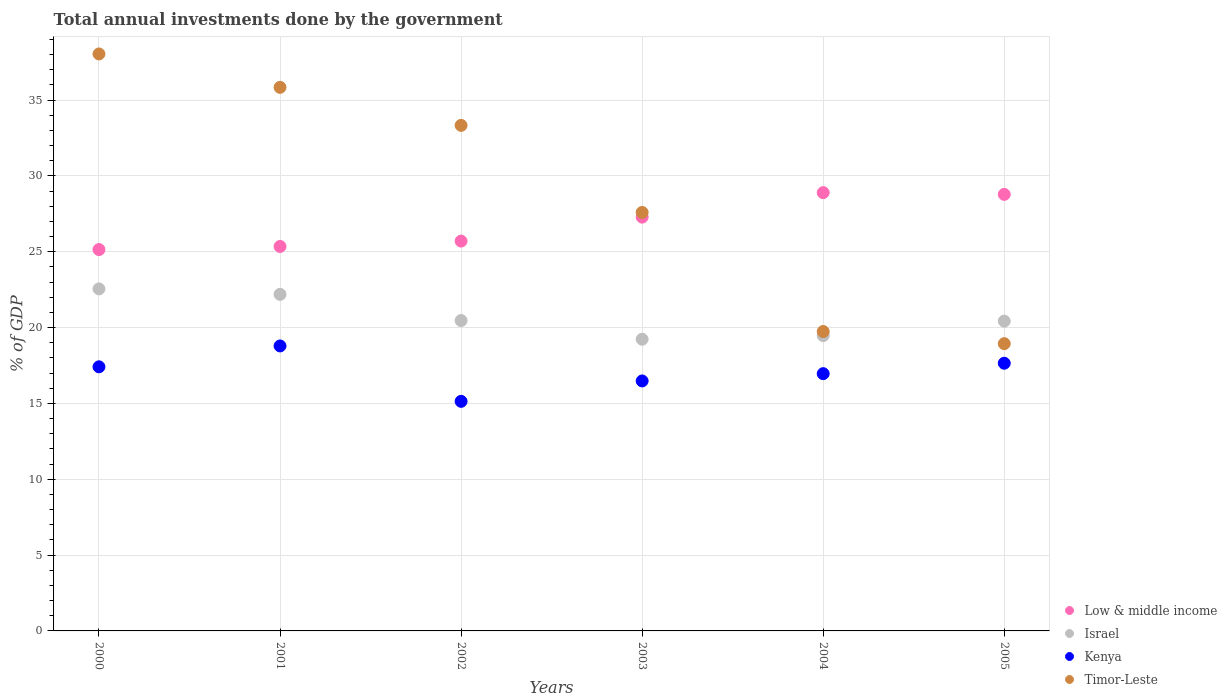How many different coloured dotlines are there?
Your answer should be compact. 4. What is the total annual investments done by the government in Kenya in 2002?
Your answer should be very brief. 15.14. Across all years, what is the maximum total annual investments done by the government in Timor-Leste?
Keep it short and to the point. 38.04. Across all years, what is the minimum total annual investments done by the government in Timor-Leste?
Offer a terse response. 18.94. What is the total total annual investments done by the government in Timor-Leste in the graph?
Offer a very short reply. 173.49. What is the difference between the total annual investments done by the government in Israel in 2001 and that in 2003?
Keep it short and to the point. 2.96. What is the difference between the total annual investments done by the government in Israel in 2004 and the total annual investments done by the government in Low & middle income in 2001?
Give a very brief answer. -5.88. What is the average total annual investments done by the government in Israel per year?
Give a very brief answer. 20.72. In the year 2005, what is the difference between the total annual investments done by the government in Timor-Leste and total annual investments done by the government in Israel?
Provide a short and direct response. -1.49. What is the ratio of the total annual investments done by the government in Kenya in 2004 to that in 2005?
Offer a very short reply. 0.96. What is the difference between the highest and the second highest total annual investments done by the government in Israel?
Offer a very short reply. 0.36. What is the difference between the highest and the lowest total annual investments done by the government in Low & middle income?
Give a very brief answer. 3.75. Is the sum of the total annual investments done by the government in Low & middle income in 2000 and 2003 greater than the maximum total annual investments done by the government in Kenya across all years?
Keep it short and to the point. Yes. Is it the case that in every year, the sum of the total annual investments done by the government in Israel and total annual investments done by the government in Timor-Leste  is greater than the sum of total annual investments done by the government in Low & middle income and total annual investments done by the government in Kenya?
Give a very brief answer. No. Is it the case that in every year, the sum of the total annual investments done by the government in Timor-Leste and total annual investments done by the government in Low & middle income  is greater than the total annual investments done by the government in Israel?
Ensure brevity in your answer.  Yes. How many dotlines are there?
Give a very brief answer. 4. What is the difference between two consecutive major ticks on the Y-axis?
Provide a succinct answer. 5. Are the values on the major ticks of Y-axis written in scientific E-notation?
Your answer should be very brief. No. Does the graph contain any zero values?
Your response must be concise. No. Does the graph contain grids?
Keep it short and to the point. Yes. How are the legend labels stacked?
Your response must be concise. Vertical. What is the title of the graph?
Your answer should be compact. Total annual investments done by the government. Does "Bahrain" appear as one of the legend labels in the graph?
Offer a terse response. No. What is the label or title of the Y-axis?
Make the answer very short. % of GDP. What is the % of GDP of Low & middle income in 2000?
Ensure brevity in your answer.  25.15. What is the % of GDP of Israel in 2000?
Your answer should be very brief. 22.55. What is the % of GDP of Kenya in 2000?
Make the answer very short. 17.41. What is the % of GDP in Timor-Leste in 2000?
Offer a very short reply. 38.04. What is the % of GDP in Low & middle income in 2001?
Your response must be concise. 25.35. What is the % of GDP in Israel in 2001?
Keep it short and to the point. 22.19. What is the % of GDP in Kenya in 2001?
Keep it short and to the point. 18.79. What is the % of GDP in Timor-Leste in 2001?
Keep it short and to the point. 35.84. What is the % of GDP in Low & middle income in 2002?
Offer a terse response. 25.7. What is the % of GDP of Israel in 2002?
Your answer should be compact. 20.47. What is the % of GDP in Kenya in 2002?
Offer a terse response. 15.14. What is the % of GDP of Timor-Leste in 2002?
Your answer should be very brief. 33.33. What is the % of GDP of Low & middle income in 2003?
Provide a succinct answer. 27.28. What is the % of GDP in Israel in 2003?
Offer a very short reply. 19.23. What is the % of GDP in Kenya in 2003?
Keep it short and to the point. 16.48. What is the % of GDP in Timor-Leste in 2003?
Your answer should be compact. 27.59. What is the % of GDP in Low & middle income in 2004?
Your answer should be very brief. 28.9. What is the % of GDP in Israel in 2004?
Your response must be concise. 19.47. What is the % of GDP in Kenya in 2004?
Offer a terse response. 16.96. What is the % of GDP of Timor-Leste in 2004?
Ensure brevity in your answer.  19.74. What is the % of GDP of Low & middle income in 2005?
Provide a short and direct response. 28.78. What is the % of GDP of Israel in 2005?
Give a very brief answer. 20.43. What is the % of GDP of Kenya in 2005?
Your answer should be compact. 17.65. What is the % of GDP of Timor-Leste in 2005?
Give a very brief answer. 18.94. Across all years, what is the maximum % of GDP of Low & middle income?
Offer a terse response. 28.9. Across all years, what is the maximum % of GDP of Israel?
Provide a succinct answer. 22.55. Across all years, what is the maximum % of GDP of Kenya?
Provide a short and direct response. 18.79. Across all years, what is the maximum % of GDP of Timor-Leste?
Offer a very short reply. 38.04. Across all years, what is the minimum % of GDP of Low & middle income?
Ensure brevity in your answer.  25.15. Across all years, what is the minimum % of GDP in Israel?
Give a very brief answer. 19.23. Across all years, what is the minimum % of GDP of Kenya?
Your answer should be compact. 15.14. Across all years, what is the minimum % of GDP in Timor-Leste?
Your answer should be compact. 18.94. What is the total % of GDP in Low & middle income in the graph?
Your answer should be very brief. 161.16. What is the total % of GDP in Israel in the graph?
Your response must be concise. 124.34. What is the total % of GDP of Kenya in the graph?
Provide a succinct answer. 102.44. What is the total % of GDP of Timor-Leste in the graph?
Provide a succinct answer. 173.49. What is the difference between the % of GDP in Low & middle income in 2000 and that in 2001?
Offer a terse response. -0.2. What is the difference between the % of GDP in Israel in 2000 and that in 2001?
Offer a very short reply. 0.36. What is the difference between the % of GDP of Kenya in 2000 and that in 2001?
Give a very brief answer. -1.38. What is the difference between the % of GDP in Timor-Leste in 2000 and that in 2001?
Provide a succinct answer. 2.2. What is the difference between the % of GDP of Low & middle income in 2000 and that in 2002?
Provide a short and direct response. -0.56. What is the difference between the % of GDP of Israel in 2000 and that in 2002?
Your response must be concise. 2.09. What is the difference between the % of GDP of Kenya in 2000 and that in 2002?
Ensure brevity in your answer.  2.28. What is the difference between the % of GDP of Timor-Leste in 2000 and that in 2002?
Offer a terse response. 4.71. What is the difference between the % of GDP in Low & middle income in 2000 and that in 2003?
Your answer should be compact. -2.14. What is the difference between the % of GDP of Israel in 2000 and that in 2003?
Your answer should be very brief. 3.32. What is the difference between the % of GDP of Kenya in 2000 and that in 2003?
Keep it short and to the point. 0.93. What is the difference between the % of GDP in Timor-Leste in 2000 and that in 2003?
Make the answer very short. 10.45. What is the difference between the % of GDP of Low & middle income in 2000 and that in 2004?
Your answer should be compact. -3.75. What is the difference between the % of GDP of Israel in 2000 and that in 2004?
Make the answer very short. 3.08. What is the difference between the % of GDP of Kenya in 2000 and that in 2004?
Ensure brevity in your answer.  0.45. What is the difference between the % of GDP of Timor-Leste in 2000 and that in 2004?
Keep it short and to the point. 18.3. What is the difference between the % of GDP of Low & middle income in 2000 and that in 2005?
Ensure brevity in your answer.  -3.64. What is the difference between the % of GDP in Israel in 2000 and that in 2005?
Your answer should be compact. 2.13. What is the difference between the % of GDP in Kenya in 2000 and that in 2005?
Provide a short and direct response. -0.24. What is the difference between the % of GDP in Timor-Leste in 2000 and that in 2005?
Provide a succinct answer. 19.1. What is the difference between the % of GDP in Low & middle income in 2001 and that in 2002?
Provide a short and direct response. -0.35. What is the difference between the % of GDP of Israel in 2001 and that in 2002?
Ensure brevity in your answer.  1.73. What is the difference between the % of GDP in Kenya in 2001 and that in 2002?
Ensure brevity in your answer.  3.65. What is the difference between the % of GDP in Timor-Leste in 2001 and that in 2002?
Ensure brevity in your answer.  2.51. What is the difference between the % of GDP of Low & middle income in 2001 and that in 2003?
Offer a terse response. -1.93. What is the difference between the % of GDP of Israel in 2001 and that in 2003?
Offer a terse response. 2.96. What is the difference between the % of GDP in Kenya in 2001 and that in 2003?
Your answer should be very brief. 2.31. What is the difference between the % of GDP in Timor-Leste in 2001 and that in 2003?
Your response must be concise. 8.25. What is the difference between the % of GDP of Low & middle income in 2001 and that in 2004?
Keep it short and to the point. -3.55. What is the difference between the % of GDP in Israel in 2001 and that in 2004?
Keep it short and to the point. 2.72. What is the difference between the % of GDP of Kenya in 2001 and that in 2004?
Ensure brevity in your answer.  1.83. What is the difference between the % of GDP of Timor-Leste in 2001 and that in 2004?
Your answer should be very brief. 16.1. What is the difference between the % of GDP of Low & middle income in 2001 and that in 2005?
Your answer should be very brief. -3.43. What is the difference between the % of GDP in Israel in 2001 and that in 2005?
Offer a terse response. 1.76. What is the difference between the % of GDP in Kenya in 2001 and that in 2005?
Provide a short and direct response. 1.14. What is the difference between the % of GDP of Timor-Leste in 2001 and that in 2005?
Your response must be concise. 16.9. What is the difference between the % of GDP in Low & middle income in 2002 and that in 2003?
Make the answer very short. -1.58. What is the difference between the % of GDP of Israel in 2002 and that in 2003?
Keep it short and to the point. 1.23. What is the difference between the % of GDP in Kenya in 2002 and that in 2003?
Your answer should be compact. -1.34. What is the difference between the % of GDP of Timor-Leste in 2002 and that in 2003?
Your answer should be very brief. 5.74. What is the difference between the % of GDP in Low & middle income in 2002 and that in 2004?
Your answer should be very brief. -3.19. What is the difference between the % of GDP of Israel in 2002 and that in 2004?
Make the answer very short. 0.99. What is the difference between the % of GDP in Kenya in 2002 and that in 2004?
Offer a very short reply. -1.82. What is the difference between the % of GDP in Timor-Leste in 2002 and that in 2004?
Provide a succinct answer. 13.59. What is the difference between the % of GDP of Low & middle income in 2002 and that in 2005?
Keep it short and to the point. -3.08. What is the difference between the % of GDP in Israel in 2002 and that in 2005?
Give a very brief answer. 0.04. What is the difference between the % of GDP in Kenya in 2002 and that in 2005?
Your response must be concise. -2.51. What is the difference between the % of GDP in Timor-Leste in 2002 and that in 2005?
Offer a terse response. 14.39. What is the difference between the % of GDP in Low & middle income in 2003 and that in 2004?
Give a very brief answer. -1.62. What is the difference between the % of GDP of Israel in 2003 and that in 2004?
Your answer should be compact. -0.24. What is the difference between the % of GDP of Kenya in 2003 and that in 2004?
Offer a terse response. -0.48. What is the difference between the % of GDP of Timor-Leste in 2003 and that in 2004?
Your answer should be compact. 7.85. What is the difference between the % of GDP of Low & middle income in 2003 and that in 2005?
Your answer should be compact. -1.5. What is the difference between the % of GDP of Israel in 2003 and that in 2005?
Offer a very short reply. -1.2. What is the difference between the % of GDP of Kenya in 2003 and that in 2005?
Your response must be concise. -1.17. What is the difference between the % of GDP of Timor-Leste in 2003 and that in 2005?
Your answer should be compact. 8.65. What is the difference between the % of GDP in Low & middle income in 2004 and that in 2005?
Your answer should be compact. 0.12. What is the difference between the % of GDP in Israel in 2004 and that in 2005?
Your response must be concise. -0.96. What is the difference between the % of GDP of Kenya in 2004 and that in 2005?
Make the answer very short. -0.69. What is the difference between the % of GDP of Timor-Leste in 2004 and that in 2005?
Offer a terse response. 0.8. What is the difference between the % of GDP of Low & middle income in 2000 and the % of GDP of Israel in 2001?
Your answer should be very brief. 2.95. What is the difference between the % of GDP in Low & middle income in 2000 and the % of GDP in Kenya in 2001?
Provide a short and direct response. 6.35. What is the difference between the % of GDP in Low & middle income in 2000 and the % of GDP in Timor-Leste in 2001?
Offer a very short reply. -10.7. What is the difference between the % of GDP of Israel in 2000 and the % of GDP of Kenya in 2001?
Your response must be concise. 3.76. What is the difference between the % of GDP of Israel in 2000 and the % of GDP of Timor-Leste in 2001?
Your response must be concise. -13.29. What is the difference between the % of GDP in Kenya in 2000 and the % of GDP in Timor-Leste in 2001?
Your answer should be very brief. -18.43. What is the difference between the % of GDP in Low & middle income in 2000 and the % of GDP in Israel in 2002?
Give a very brief answer. 4.68. What is the difference between the % of GDP of Low & middle income in 2000 and the % of GDP of Kenya in 2002?
Ensure brevity in your answer.  10.01. What is the difference between the % of GDP in Low & middle income in 2000 and the % of GDP in Timor-Leste in 2002?
Provide a short and direct response. -8.19. What is the difference between the % of GDP in Israel in 2000 and the % of GDP in Kenya in 2002?
Make the answer very short. 7.42. What is the difference between the % of GDP of Israel in 2000 and the % of GDP of Timor-Leste in 2002?
Provide a succinct answer. -10.78. What is the difference between the % of GDP in Kenya in 2000 and the % of GDP in Timor-Leste in 2002?
Offer a terse response. -15.92. What is the difference between the % of GDP of Low & middle income in 2000 and the % of GDP of Israel in 2003?
Your answer should be very brief. 5.91. What is the difference between the % of GDP of Low & middle income in 2000 and the % of GDP of Kenya in 2003?
Make the answer very short. 8.66. What is the difference between the % of GDP of Low & middle income in 2000 and the % of GDP of Timor-Leste in 2003?
Offer a terse response. -2.45. What is the difference between the % of GDP of Israel in 2000 and the % of GDP of Kenya in 2003?
Provide a short and direct response. 6.07. What is the difference between the % of GDP of Israel in 2000 and the % of GDP of Timor-Leste in 2003?
Your answer should be compact. -5.04. What is the difference between the % of GDP in Kenya in 2000 and the % of GDP in Timor-Leste in 2003?
Make the answer very short. -10.18. What is the difference between the % of GDP in Low & middle income in 2000 and the % of GDP in Israel in 2004?
Your answer should be compact. 5.67. What is the difference between the % of GDP in Low & middle income in 2000 and the % of GDP in Kenya in 2004?
Provide a short and direct response. 8.18. What is the difference between the % of GDP of Low & middle income in 2000 and the % of GDP of Timor-Leste in 2004?
Keep it short and to the point. 5.4. What is the difference between the % of GDP of Israel in 2000 and the % of GDP of Kenya in 2004?
Provide a short and direct response. 5.59. What is the difference between the % of GDP of Israel in 2000 and the % of GDP of Timor-Leste in 2004?
Offer a terse response. 2.81. What is the difference between the % of GDP in Kenya in 2000 and the % of GDP in Timor-Leste in 2004?
Give a very brief answer. -2.33. What is the difference between the % of GDP of Low & middle income in 2000 and the % of GDP of Israel in 2005?
Your response must be concise. 4.72. What is the difference between the % of GDP in Low & middle income in 2000 and the % of GDP in Kenya in 2005?
Your answer should be very brief. 7.5. What is the difference between the % of GDP of Low & middle income in 2000 and the % of GDP of Timor-Leste in 2005?
Your answer should be compact. 6.2. What is the difference between the % of GDP in Israel in 2000 and the % of GDP in Kenya in 2005?
Offer a very short reply. 4.9. What is the difference between the % of GDP of Israel in 2000 and the % of GDP of Timor-Leste in 2005?
Provide a short and direct response. 3.61. What is the difference between the % of GDP of Kenya in 2000 and the % of GDP of Timor-Leste in 2005?
Your response must be concise. -1.53. What is the difference between the % of GDP of Low & middle income in 2001 and the % of GDP of Israel in 2002?
Your response must be concise. 4.88. What is the difference between the % of GDP in Low & middle income in 2001 and the % of GDP in Kenya in 2002?
Offer a very short reply. 10.21. What is the difference between the % of GDP in Low & middle income in 2001 and the % of GDP in Timor-Leste in 2002?
Give a very brief answer. -7.98. What is the difference between the % of GDP in Israel in 2001 and the % of GDP in Kenya in 2002?
Give a very brief answer. 7.05. What is the difference between the % of GDP in Israel in 2001 and the % of GDP in Timor-Leste in 2002?
Keep it short and to the point. -11.14. What is the difference between the % of GDP in Kenya in 2001 and the % of GDP in Timor-Leste in 2002?
Offer a very short reply. -14.54. What is the difference between the % of GDP in Low & middle income in 2001 and the % of GDP in Israel in 2003?
Ensure brevity in your answer.  6.12. What is the difference between the % of GDP of Low & middle income in 2001 and the % of GDP of Kenya in 2003?
Offer a terse response. 8.87. What is the difference between the % of GDP of Low & middle income in 2001 and the % of GDP of Timor-Leste in 2003?
Your answer should be very brief. -2.24. What is the difference between the % of GDP of Israel in 2001 and the % of GDP of Kenya in 2003?
Offer a terse response. 5.71. What is the difference between the % of GDP in Israel in 2001 and the % of GDP in Timor-Leste in 2003?
Offer a terse response. -5.4. What is the difference between the % of GDP in Kenya in 2001 and the % of GDP in Timor-Leste in 2003?
Offer a very short reply. -8.8. What is the difference between the % of GDP in Low & middle income in 2001 and the % of GDP in Israel in 2004?
Keep it short and to the point. 5.88. What is the difference between the % of GDP of Low & middle income in 2001 and the % of GDP of Kenya in 2004?
Your answer should be very brief. 8.39. What is the difference between the % of GDP in Low & middle income in 2001 and the % of GDP in Timor-Leste in 2004?
Ensure brevity in your answer.  5.61. What is the difference between the % of GDP of Israel in 2001 and the % of GDP of Kenya in 2004?
Provide a short and direct response. 5.23. What is the difference between the % of GDP in Israel in 2001 and the % of GDP in Timor-Leste in 2004?
Provide a succinct answer. 2.45. What is the difference between the % of GDP in Kenya in 2001 and the % of GDP in Timor-Leste in 2004?
Your answer should be very brief. -0.95. What is the difference between the % of GDP in Low & middle income in 2001 and the % of GDP in Israel in 2005?
Make the answer very short. 4.92. What is the difference between the % of GDP in Low & middle income in 2001 and the % of GDP in Kenya in 2005?
Keep it short and to the point. 7.7. What is the difference between the % of GDP in Low & middle income in 2001 and the % of GDP in Timor-Leste in 2005?
Offer a terse response. 6.41. What is the difference between the % of GDP in Israel in 2001 and the % of GDP in Kenya in 2005?
Make the answer very short. 4.54. What is the difference between the % of GDP of Israel in 2001 and the % of GDP of Timor-Leste in 2005?
Make the answer very short. 3.25. What is the difference between the % of GDP of Kenya in 2001 and the % of GDP of Timor-Leste in 2005?
Keep it short and to the point. -0.15. What is the difference between the % of GDP of Low & middle income in 2002 and the % of GDP of Israel in 2003?
Offer a very short reply. 6.47. What is the difference between the % of GDP in Low & middle income in 2002 and the % of GDP in Kenya in 2003?
Provide a short and direct response. 9.22. What is the difference between the % of GDP in Low & middle income in 2002 and the % of GDP in Timor-Leste in 2003?
Offer a very short reply. -1.89. What is the difference between the % of GDP in Israel in 2002 and the % of GDP in Kenya in 2003?
Offer a very short reply. 3.98. What is the difference between the % of GDP in Israel in 2002 and the % of GDP in Timor-Leste in 2003?
Your answer should be compact. -7.13. What is the difference between the % of GDP in Kenya in 2002 and the % of GDP in Timor-Leste in 2003?
Your answer should be very brief. -12.46. What is the difference between the % of GDP of Low & middle income in 2002 and the % of GDP of Israel in 2004?
Keep it short and to the point. 6.23. What is the difference between the % of GDP in Low & middle income in 2002 and the % of GDP in Kenya in 2004?
Your response must be concise. 8.74. What is the difference between the % of GDP in Low & middle income in 2002 and the % of GDP in Timor-Leste in 2004?
Give a very brief answer. 5.96. What is the difference between the % of GDP of Israel in 2002 and the % of GDP of Kenya in 2004?
Offer a terse response. 3.5. What is the difference between the % of GDP in Israel in 2002 and the % of GDP in Timor-Leste in 2004?
Provide a short and direct response. 0.72. What is the difference between the % of GDP of Kenya in 2002 and the % of GDP of Timor-Leste in 2004?
Offer a very short reply. -4.6. What is the difference between the % of GDP of Low & middle income in 2002 and the % of GDP of Israel in 2005?
Keep it short and to the point. 5.28. What is the difference between the % of GDP of Low & middle income in 2002 and the % of GDP of Kenya in 2005?
Provide a succinct answer. 8.05. What is the difference between the % of GDP of Low & middle income in 2002 and the % of GDP of Timor-Leste in 2005?
Keep it short and to the point. 6.76. What is the difference between the % of GDP in Israel in 2002 and the % of GDP in Kenya in 2005?
Provide a short and direct response. 2.82. What is the difference between the % of GDP of Israel in 2002 and the % of GDP of Timor-Leste in 2005?
Your answer should be compact. 1.52. What is the difference between the % of GDP in Kenya in 2002 and the % of GDP in Timor-Leste in 2005?
Offer a terse response. -3.8. What is the difference between the % of GDP in Low & middle income in 2003 and the % of GDP in Israel in 2004?
Provide a short and direct response. 7.81. What is the difference between the % of GDP of Low & middle income in 2003 and the % of GDP of Kenya in 2004?
Your answer should be compact. 10.32. What is the difference between the % of GDP of Low & middle income in 2003 and the % of GDP of Timor-Leste in 2004?
Your answer should be very brief. 7.54. What is the difference between the % of GDP of Israel in 2003 and the % of GDP of Kenya in 2004?
Your answer should be compact. 2.27. What is the difference between the % of GDP in Israel in 2003 and the % of GDP in Timor-Leste in 2004?
Offer a terse response. -0.51. What is the difference between the % of GDP of Kenya in 2003 and the % of GDP of Timor-Leste in 2004?
Make the answer very short. -3.26. What is the difference between the % of GDP of Low & middle income in 2003 and the % of GDP of Israel in 2005?
Give a very brief answer. 6.86. What is the difference between the % of GDP of Low & middle income in 2003 and the % of GDP of Kenya in 2005?
Keep it short and to the point. 9.63. What is the difference between the % of GDP in Low & middle income in 2003 and the % of GDP in Timor-Leste in 2005?
Your answer should be very brief. 8.34. What is the difference between the % of GDP in Israel in 2003 and the % of GDP in Kenya in 2005?
Make the answer very short. 1.58. What is the difference between the % of GDP of Israel in 2003 and the % of GDP of Timor-Leste in 2005?
Offer a terse response. 0.29. What is the difference between the % of GDP in Kenya in 2003 and the % of GDP in Timor-Leste in 2005?
Your answer should be compact. -2.46. What is the difference between the % of GDP of Low & middle income in 2004 and the % of GDP of Israel in 2005?
Ensure brevity in your answer.  8.47. What is the difference between the % of GDP of Low & middle income in 2004 and the % of GDP of Kenya in 2005?
Ensure brevity in your answer.  11.25. What is the difference between the % of GDP of Low & middle income in 2004 and the % of GDP of Timor-Leste in 2005?
Your answer should be compact. 9.96. What is the difference between the % of GDP in Israel in 2004 and the % of GDP in Kenya in 2005?
Ensure brevity in your answer.  1.82. What is the difference between the % of GDP in Israel in 2004 and the % of GDP in Timor-Leste in 2005?
Ensure brevity in your answer.  0.53. What is the difference between the % of GDP in Kenya in 2004 and the % of GDP in Timor-Leste in 2005?
Provide a succinct answer. -1.98. What is the average % of GDP in Low & middle income per year?
Your answer should be compact. 26.86. What is the average % of GDP of Israel per year?
Provide a short and direct response. 20.72. What is the average % of GDP in Kenya per year?
Keep it short and to the point. 17.07. What is the average % of GDP in Timor-Leste per year?
Your answer should be very brief. 28.92. In the year 2000, what is the difference between the % of GDP in Low & middle income and % of GDP in Israel?
Provide a succinct answer. 2.59. In the year 2000, what is the difference between the % of GDP of Low & middle income and % of GDP of Kenya?
Provide a short and direct response. 7.73. In the year 2000, what is the difference between the % of GDP in Low & middle income and % of GDP in Timor-Leste?
Give a very brief answer. -12.9. In the year 2000, what is the difference between the % of GDP in Israel and % of GDP in Kenya?
Your answer should be very brief. 5.14. In the year 2000, what is the difference between the % of GDP in Israel and % of GDP in Timor-Leste?
Keep it short and to the point. -15.49. In the year 2000, what is the difference between the % of GDP of Kenya and % of GDP of Timor-Leste?
Offer a very short reply. -20.63. In the year 2001, what is the difference between the % of GDP of Low & middle income and % of GDP of Israel?
Provide a succinct answer. 3.16. In the year 2001, what is the difference between the % of GDP of Low & middle income and % of GDP of Kenya?
Your answer should be very brief. 6.56. In the year 2001, what is the difference between the % of GDP of Low & middle income and % of GDP of Timor-Leste?
Your answer should be very brief. -10.49. In the year 2001, what is the difference between the % of GDP in Israel and % of GDP in Kenya?
Make the answer very short. 3.4. In the year 2001, what is the difference between the % of GDP in Israel and % of GDP in Timor-Leste?
Ensure brevity in your answer.  -13.65. In the year 2001, what is the difference between the % of GDP of Kenya and % of GDP of Timor-Leste?
Ensure brevity in your answer.  -17.05. In the year 2002, what is the difference between the % of GDP in Low & middle income and % of GDP in Israel?
Your answer should be very brief. 5.24. In the year 2002, what is the difference between the % of GDP in Low & middle income and % of GDP in Kenya?
Keep it short and to the point. 10.57. In the year 2002, what is the difference between the % of GDP of Low & middle income and % of GDP of Timor-Leste?
Your answer should be compact. -7.63. In the year 2002, what is the difference between the % of GDP of Israel and % of GDP of Kenya?
Provide a succinct answer. 5.33. In the year 2002, what is the difference between the % of GDP of Israel and % of GDP of Timor-Leste?
Your answer should be very brief. -12.87. In the year 2002, what is the difference between the % of GDP in Kenya and % of GDP in Timor-Leste?
Keep it short and to the point. -18.2. In the year 2003, what is the difference between the % of GDP of Low & middle income and % of GDP of Israel?
Ensure brevity in your answer.  8.05. In the year 2003, what is the difference between the % of GDP in Low & middle income and % of GDP in Kenya?
Offer a terse response. 10.8. In the year 2003, what is the difference between the % of GDP of Low & middle income and % of GDP of Timor-Leste?
Provide a short and direct response. -0.31. In the year 2003, what is the difference between the % of GDP in Israel and % of GDP in Kenya?
Make the answer very short. 2.75. In the year 2003, what is the difference between the % of GDP in Israel and % of GDP in Timor-Leste?
Give a very brief answer. -8.36. In the year 2003, what is the difference between the % of GDP of Kenya and % of GDP of Timor-Leste?
Provide a short and direct response. -11.11. In the year 2004, what is the difference between the % of GDP in Low & middle income and % of GDP in Israel?
Keep it short and to the point. 9.43. In the year 2004, what is the difference between the % of GDP in Low & middle income and % of GDP in Kenya?
Provide a short and direct response. 11.94. In the year 2004, what is the difference between the % of GDP in Low & middle income and % of GDP in Timor-Leste?
Give a very brief answer. 9.16. In the year 2004, what is the difference between the % of GDP in Israel and % of GDP in Kenya?
Make the answer very short. 2.51. In the year 2004, what is the difference between the % of GDP of Israel and % of GDP of Timor-Leste?
Ensure brevity in your answer.  -0.27. In the year 2004, what is the difference between the % of GDP of Kenya and % of GDP of Timor-Leste?
Ensure brevity in your answer.  -2.78. In the year 2005, what is the difference between the % of GDP of Low & middle income and % of GDP of Israel?
Ensure brevity in your answer.  8.36. In the year 2005, what is the difference between the % of GDP in Low & middle income and % of GDP in Kenya?
Ensure brevity in your answer.  11.13. In the year 2005, what is the difference between the % of GDP of Low & middle income and % of GDP of Timor-Leste?
Keep it short and to the point. 9.84. In the year 2005, what is the difference between the % of GDP in Israel and % of GDP in Kenya?
Your response must be concise. 2.78. In the year 2005, what is the difference between the % of GDP of Israel and % of GDP of Timor-Leste?
Ensure brevity in your answer.  1.49. In the year 2005, what is the difference between the % of GDP of Kenya and % of GDP of Timor-Leste?
Your answer should be very brief. -1.29. What is the ratio of the % of GDP of Low & middle income in 2000 to that in 2001?
Ensure brevity in your answer.  0.99. What is the ratio of the % of GDP in Israel in 2000 to that in 2001?
Ensure brevity in your answer.  1.02. What is the ratio of the % of GDP of Kenya in 2000 to that in 2001?
Your response must be concise. 0.93. What is the ratio of the % of GDP of Timor-Leste in 2000 to that in 2001?
Give a very brief answer. 1.06. What is the ratio of the % of GDP in Low & middle income in 2000 to that in 2002?
Your response must be concise. 0.98. What is the ratio of the % of GDP of Israel in 2000 to that in 2002?
Your answer should be compact. 1.1. What is the ratio of the % of GDP of Kenya in 2000 to that in 2002?
Keep it short and to the point. 1.15. What is the ratio of the % of GDP in Timor-Leste in 2000 to that in 2002?
Make the answer very short. 1.14. What is the ratio of the % of GDP of Low & middle income in 2000 to that in 2003?
Provide a succinct answer. 0.92. What is the ratio of the % of GDP in Israel in 2000 to that in 2003?
Your answer should be compact. 1.17. What is the ratio of the % of GDP of Kenya in 2000 to that in 2003?
Your response must be concise. 1.06. What is the ratio of the % of GDP of Timor-Leste in 2000 to that in 2003?
Your answer should be very brief. 1.38. What is the ratio of the % of GDP of Low & middle income in 2000 to that in 2004?
Give a very brief answer. 0.87. What is the ratio of the % of GDP of Israel in 2000 to that in 2004?
Offer a very short reply. 1.16. What is the ratio of the % of GDP in Kenya in 2000 to that in 2004?
Keep it short and to the point. 1.03. What is the ratio of the % of GDP of Timor-Leste in 2000 to that in 2004?
Provide a short and direct response. 1.93. What is the ratio of the % of GDP in Low & middle income in 2000 to that in 2005?
Your answer should be compact. 0.87. What is the ratio of the % of GDP of Israel in 2000 to that in 2005?
Your answer should be compact. 1.1. What is the ratio of the % of GDP in Kenya in 2000 to that in 2005?
Give a very brief answer. 0.99. What is the ratio of the % of GDP in Timor-Leste in 2000 to that in 2005?
Provide a short and direct response. 2.01. What is the ratio of the % of GDP of Low & middle income in 2001 to that in 2002?
Your response must be concise. 0.99. What is the ratio of the % of GDP in Israel in 2001 to that in 2002?
Your answer should be very brief. 1.08. What is the ratio of the % of GDP of Kenya in 2001 to that in 2002?
Your answer should be compact. 1.24. What is the ratio of the % of GDP of Timor-Leste in 2001 to that in 2002?
Your answer should be compact. 1.08. What is the ratio of the % of GDP in Low & middle income in 2001 to that in 2003?
Provide a succinct answer. 0.93. What is the ratio of the % of GDP of Israel in 2001 to that in 2003?
Offer a very short reply. 1.15. What is the ratio of the % of GDP of Kenya in 2001 to that in 2003?
Provide a short and direct response. 1.14. What is the ratio of the % of GDP of Timor-Leste in 2001 to that in 2003?
Provide a succinct answer. 1.3. What is the ratio of the % of GDP of Low & middle income in 2001 to that in 2004?
Provide a short and direct response. 0.88. What is the ratio of the % of GDP in Israel in 2001 to that in 2004?
Offer a terse response. 1.14. What is the ratio of the % of GDP of Kenya in 2001 to that in 2004?
Offer a terse response. 1.11. What is the ratio of the % of GDP in Timor-Leste in 2001 to that in 2004?
Make the answer very short. 1.82. What is the ratio of the % of GDP of Low & middle income in 2001 to that in 2005?
Ensure brevity in your answer.  0.88. What is the ratio of the % of GDP in Israel in 2001 to that in 2005?
Your answer should be very brief. 1.09. What is the ratio of the % of GDP in Kenya in 2001 to that in 2005?
Offer a terse response. 1.06. What is the ratio of the % of GDP of Timor-Leste in 2001 to that in 2005?
Offer a terse response. 1.89. What is the ratio of the % of GDP in Low & middle income in 2002 to that in 2003?
Your answer should be compact. 0.94. What is the ratio of the % of GDP in Israel in 2002 to that in 2003?
Give a very brief answer. 1.06. What is the ratio of the % of GDP of Kenya in 2002 to that in 2003?
Provide a succinct answer. 0.92. What is the ratio of the % of GDP of Timor-Leste in 2002 to that in 2003?
Your answer should be very brief. 1.21. What is the ratio of the % of GDP of Low & middle income in 2002 to that in 2004?
Offer a very short reply. 0.89. What is the ratio of the % of GDP in Israel in 2002 to that in 2004?
Make the answer very short. 1.05. What is the ratio of the % of GDP in Kenya in 2002 to that in 2004?
Keep it short and to the point. 0.89. What is the ratio of the % of GDP in Timor-Leste in 2002 to that in 2004?
Make the answer very short. 1.69. What is the ratio of the % of GDP of Low & middle income in 2002 to that in 2005?
Offer a terse response. 0.89. What is the ratio of the % of GDP of Kenya in 2002 to that in 2005?
Keep it short and to the point. 0.86. What is the ratio of the % of GDP of Timor-Leste in 2002 to that in 2005?
Provide a succinct answer. 1.76. What is the ratio of the % of GDP in Low & middle income in 2003 to that in 2004?
Your answer should be very brief. 0.94. What is the ratio of the % of GDP of Israel in 2003 to that in 2004?
Offer a terse response. 0.99. What is the ratio of the % of GDP in Kenya in 2003 to that in 2004?
Your response must be concise. 0.97. What is the ratio of the % of GDP in Timor-Leste in 2003 to that in 2004?
Provide a short and direct response. 1.4. What is the ratio of the % of GDP of Low & middle income in 2003 to that in 2005?
Offer a very short reply. 0.95. What is the ratio of the % of GDP of Israel in 2003 to that in 2005?
Ensure brevity in your answer.  0.94. What is the ratio of the % of GDP of Kenya in 2003 to that in 2005?
Give a very brief answer. 0.93. What is the ratio of the % of GDP in Timor-Leste in 2003 to that in 2005?
Ensure brevity in your answer.  1.46. What is the ratio of the % of GDP of Israel in 2004 to that in 2005?
Offer a terse response. 0.95. What is the ratio of the % of GDP in Kenya in 2004 to that in 2005?
Give a very brief answer. 0.96. What is the ratio of the % of GDP of Timor-Leste in 2004 to that in 2005?
Your answer should be very brief. 1.04. What is the difference between the highest and the second highest % of GDP of Low & middle income?
Provide a short and direct response. 0.12. What is the difference between the highest and the second highest % of GDP of Israel?
Offer a terse response. 0.36. What is the difference between the highest and the second highest % of GDP in Kenya?
Your answer should be very brief. 1.14. What is the difference between the highest and the second highest % of GDP in Timor-Leste?
Offer a terse response. 2.2. What is the difference between the highest and the lowest % of GDP in Low & middle income?
Ensure brevity in your answer.  3.75. What is the difference between the highest and the lowest % of GDP of Israel?
Offer a terse response. 3.32. What is the difference between the highest and the lowest % of GDP of Kenya?
Your response must be concise. 3.65. What is the difference between the highest and the lowest % of GDP of Timor-Leste?
Your answer should be compact. 19.1. 